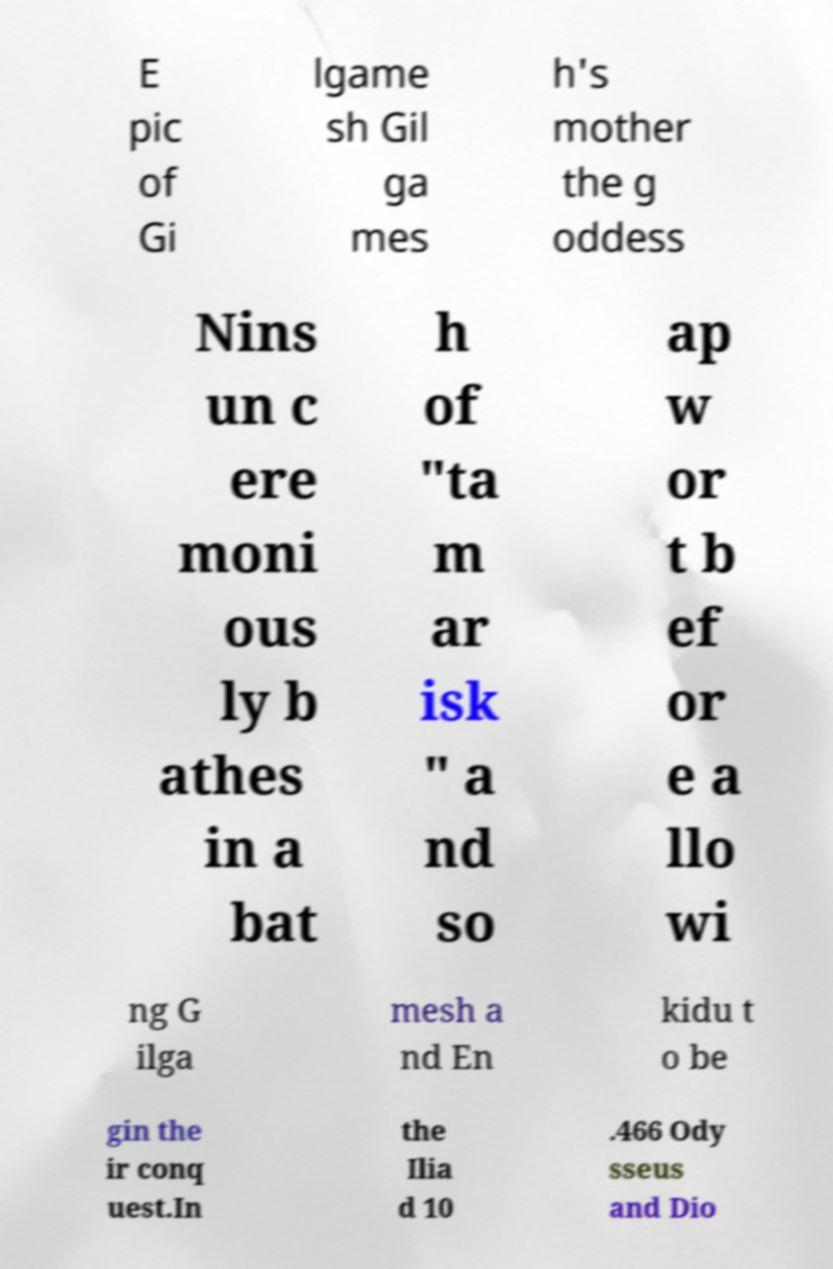Can you read and provide the text displayed in the image?This photo seems to have some interesting text. Can you extract and type it out for me? E pic of Gi lgame sh Gil ga mes h's mother the g oddess Nins un c ere moni ous ly b athes in a bat h of "ta m ar isk " a nd so ap w or t b ef or e a llo wi ng G ilga mesh a nd En kidu t o be gin the ir conq uest.In the Ilia d 10 .466 Ody sseus and Dio 